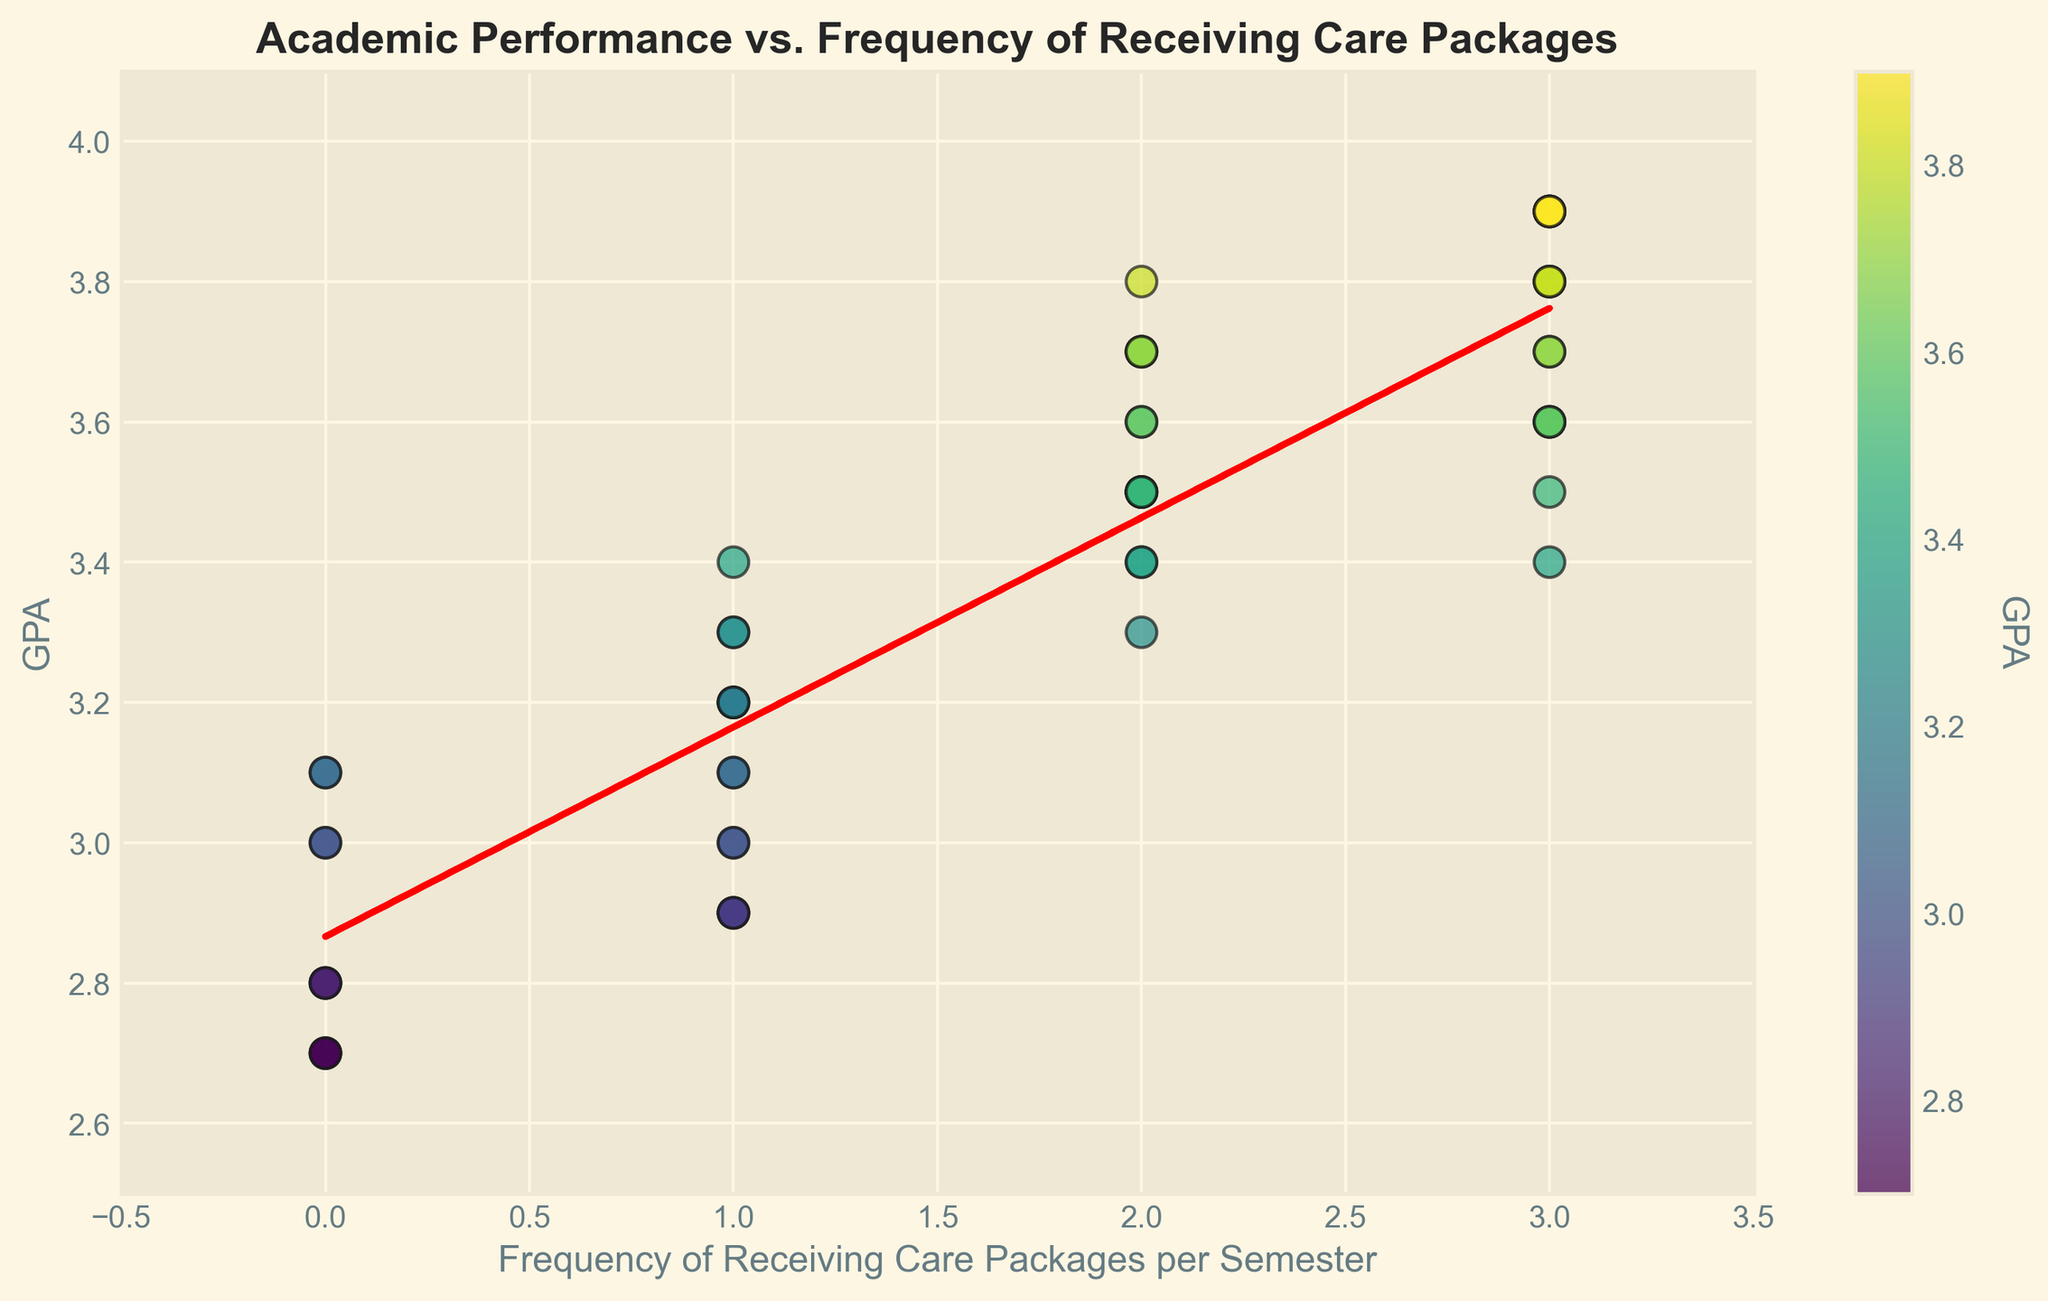What's the average GPA for students who receive care packages 3 times per semester? To find the average GPA for students receiving care packages 3 times per semester, we first identify their GPAs: 3.8, 3.6, 3.9, 3.6, 3.8, 3.9, 3.6, 3.8, 3.9, 3.5. Next, we sum these values: 3.8 + 3.6 + 3.9 + 3.6 + 3.8 + 3.9 + 3.6 + 3.8 + 3.9 + 3.5 = 37.4 and divide by the number of students (10): 37.4 / 10 = 3.74
Answer: 3.74 Which frequency of receiving care packages has the highest number of students, and what is the most common GPA within that group? First, count the students in each frequency category: 0 (6 students), 1 (12 students), 2 (13 students), 3 (19 students). The highest number is 19 for the frequency 3. Within this group, most values are 3.8 and 3.6, which repeat 3 times each.
Answer: Frequency 3, GPA 3.8 or 3.6 Is there a visible trend between the frequency of receiving care packages and the GPA? By looking at the scatter plot and the red trend line, observe that the GPA generally increases as the frequency of receiving care packages increases. This is illustrated by the upward slope of the trend line.
Answer: Yes, positive trend What is the approximate slope of the trend line? The trend line represents a linear regression line. The slope can be visually estimated from the figure, showing an upward trend. Given the data points, the slope appears to be positive and around 0.11.
Answer: Approximately 0.11 How many students have a GPA above 3.5, and how often do they receive care packages on average? Identify the students with a GPA above 3.5: 4 (3.8), 6 (3.7), 9 (3.6), 12 (3.9), 16 (3.7), 18 (3.8), 20 (3.9), 22 (3.7), 24 (3.6), 27 (3.4), 29 (3.8), 32 (3.7), 36 (3.9), 37 (3.4), 40 (3.6), 41 (3.7), 44 (3.8), 45 (3.5), 46 (3.6), 47 (3.3), 50 (3.9). There are 21 students with GPA above 3.5. Their care package frequencies are: 3, 2, 3, 3, 3, 3, 3, 2, 3, 3, 0, 3, 3, 2, 2, 3, 3, 2, 3, 1, 3. The average is (3+2+3+3+3+3+3+2+3+3+0+3+3+2+2+3+3+2+3+1+3)/21 = 2.6.
Answer: 21 students, average frequency 2.6 